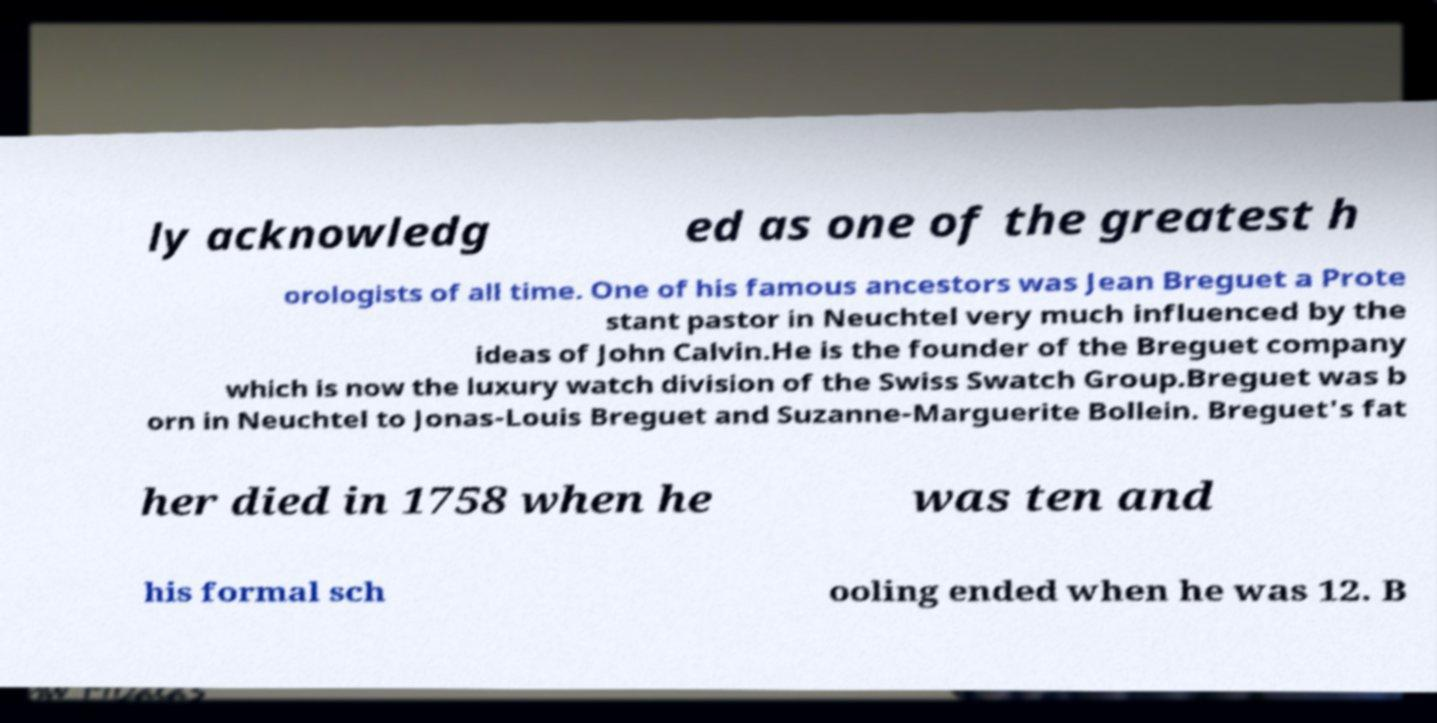Please identify and transcribe the text found in this image. ly acknowledg ed as one of the greatest h orologists of all time. One of his famous ancestors was Jean Breguet a Prote stant pastor in Neuchtel very much influenced by the ideas of John Calvin.He is the founder of the Breguet company which is now the luxury watch division of the Swiss Swatch Group.Breguet was b orn in Neuchtel to Jonas-Louis Breguet and Suzanne-Marguerite Bollein. Breguet's fat her died in 1758 when he was ten and his formal sch ooling ended when he was 12. B 